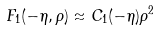<formula> <loc_0><loc_0><loc_500><loc_500>F _ { 1 } ( - \eta , \rho ) \approx C _ { 1 } ( - \eta ) \rho ^ { 2 }</formula> 